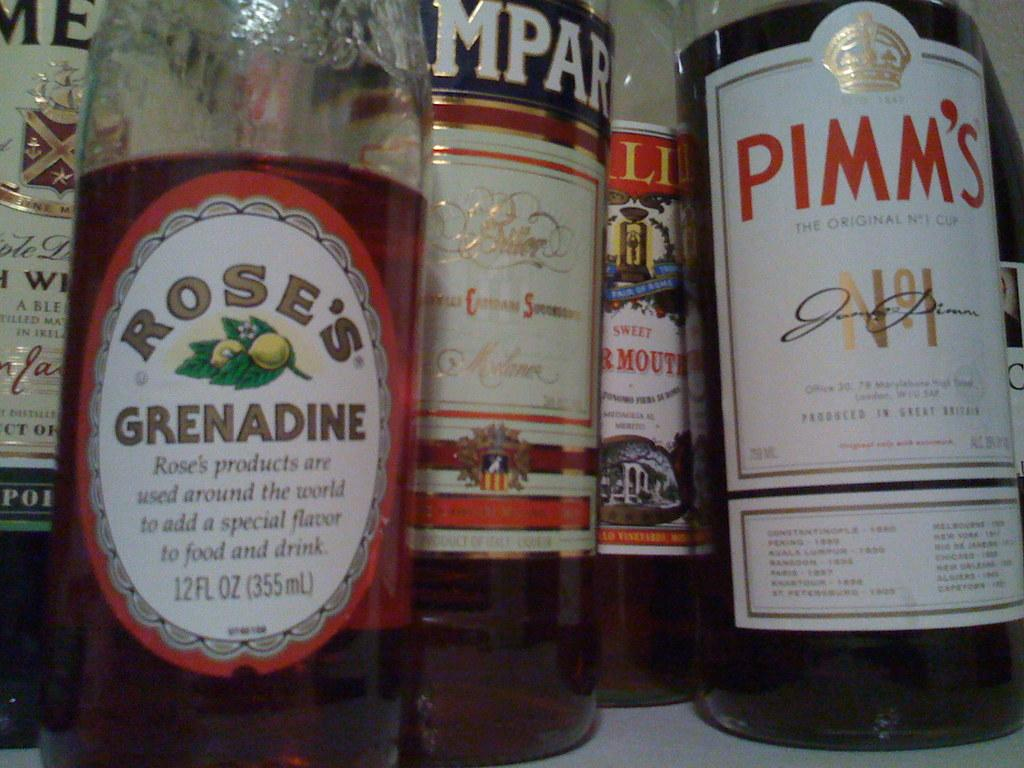<image>
Offer a succinct explanation of the picture presented. A shelf of bottles including Grenadine and Pimm's. 